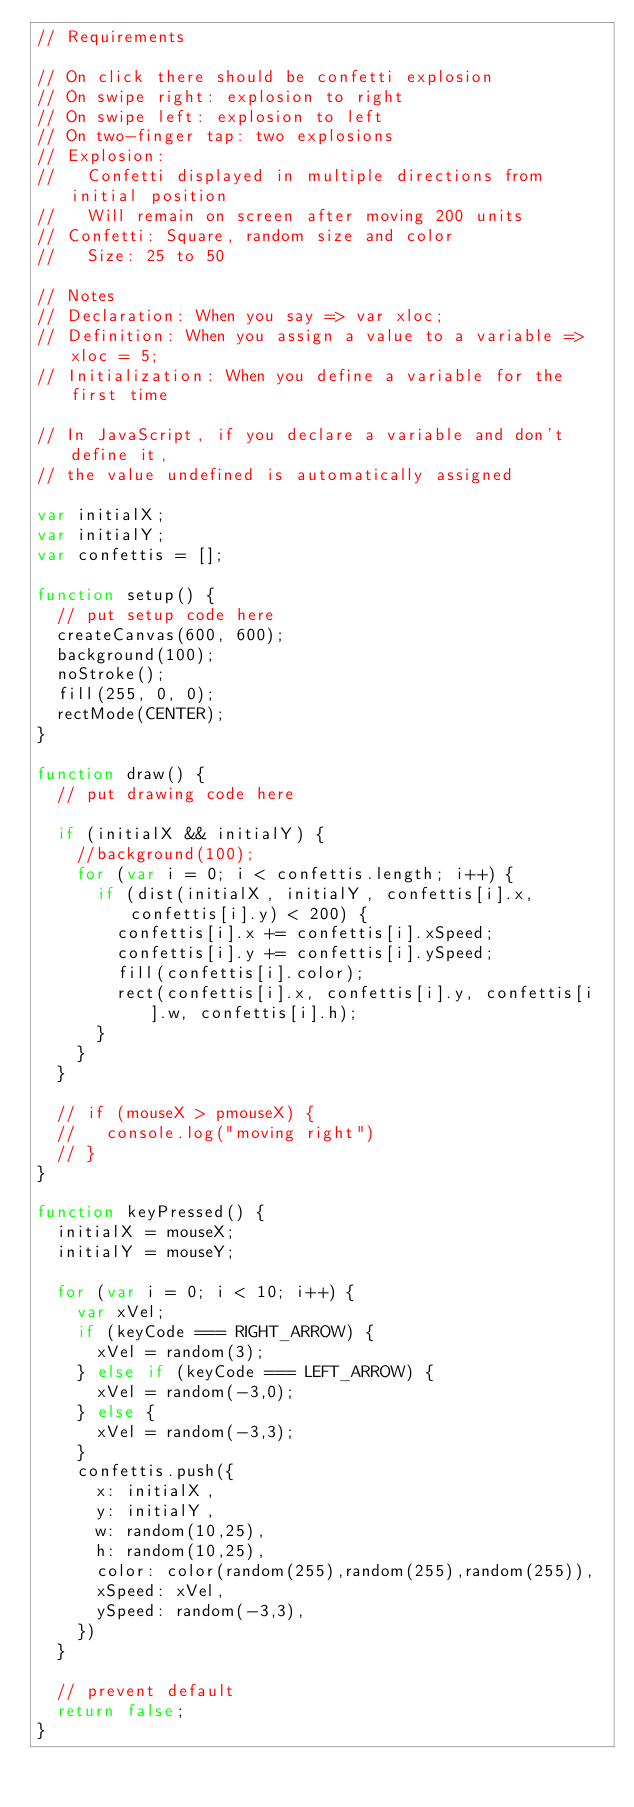Convert code to text. <code><loc_0><loc_0><loc_500><loc_500><_JavaScript_>// Requirements

// On click there should be confetti explosion
// On swipe right: explosion to right
// On swipe left: explosion to left
// On two-finger tap: two explosions
// Explosion:
//   Confetti displayed in multiple directions from initial position
//   Will remain on screen after moving 200 units
// Confetti: Square, random size and color
//   Size: 25 to 50

// Notes
// Declaration: When you say => var xloc;
// Definition: When you assign a value to a variable => xloc = 5;
// Initialization: When you define a variable for the first time

// In JavaScript, if you declare a variable and don't define it,
// the value undefined is automatically assigned

var initialX;
var initialY;
var confettis = [];

function setup() {
  // put setup code here
  createCanvas(600, 600);
  background(100);
  noStroke();
  fill(255, 0, 0);
  rectMode(CENTER);
}

function draw() {
  // put drawing code here

  if (initialX && initialY) {
    //background(100);
    for (var i = 0; i < confettis.length; i++) {
      if (dist(initialX, initialY, confettis[i].x, confettis[i].y) < 200) {
        confettis[i].x += confettis[i].xSpeed;
        confettis[i].y += confettis[i].ySpeed;
        fill(confettis[i].color);
        rect(confettis[i].x, confettis[i].y, confettis[i].w, confettis[i].h);
      }
    }
  }

  // if (mouseX > pmouseX) {
  //   console.log("moving right")
  // }
}

function keyPressed() {
  initialX = mouseX;
  initialY = mouseY;

  for (var i = 0; i < 10; i++) {
    var xVel;
    if (keyCode === RIGHT_ARROW) {
      xVel = random(3);
    } else if (keyCode === LEFT_ARROW) {
      xVel = random(-3,0);
    } else {
      xVel = random(-3,3);
    }
    confettis.push({
      x: initialX,
      y: initialY,
      w: random(10,25),
      h: random(10,25),
      color: color(random(255),random(255),random(255)),
      xSpeed: xVel,
      ySpeed: random(-3,3),
    })
  }

  // prevent default
  return false;
}
</code> 